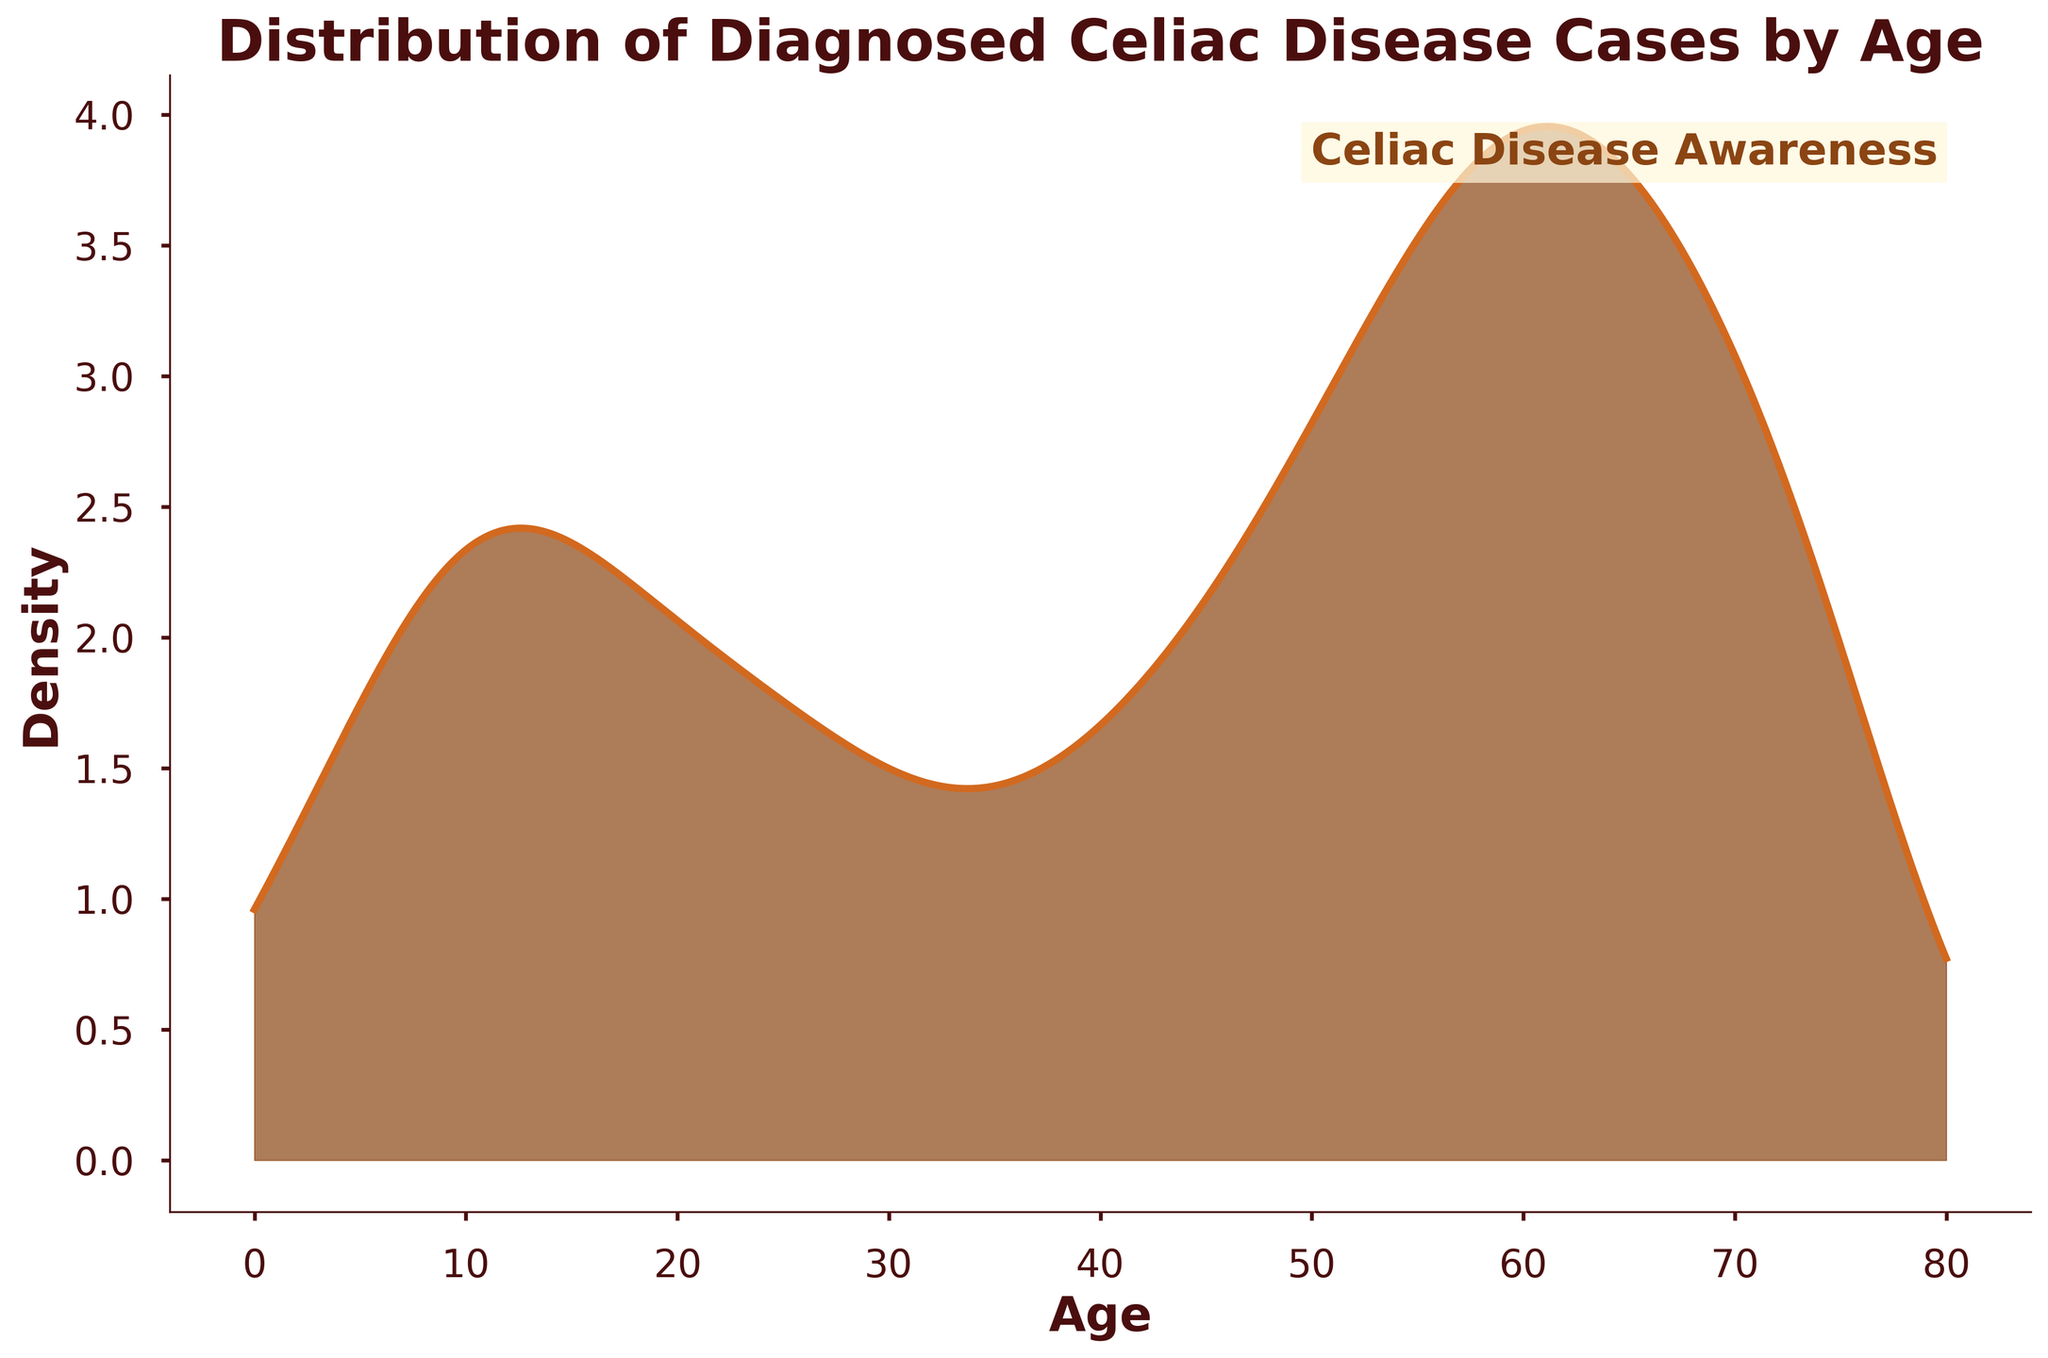What is the title of the plot? The title of the plot is located at the top of the figure and is displayed in bold.
Answer: Distribution of Diagnosed Celiac Disease Cases by Age What ages have the highest density of diagnosed Celiac disease cases? The highest density area in the figure corresponds to the peak of the plot, indicating the ages with the highest diagnosed cases.
Answer: 60-64 What is the lowest density area for diagnosed Celiac disease cases? The lowest density areas are where the plot dips closer to the baseline, indicating fewer diagnosed cases.
Answer: 0-4 How does the density of cases in the 20-24 age group compare to the 60-64 age group? The comparison involves looking at the height of the plot in the specified age ranges; the density is higher for the 60-64 group compared to the 20-24 group.
Answer: Less than Which age groups have similar densities of diagnosed Celiac disease cases? Look for areas on the plot where the curve appears at similar heights, indicating similar densities.
Answer: 45-49 and 75+ How does the density change from age 50-54 to age 60-64? Examine the plot's slope between these age ranges; the density increases as the curve rises from 50-54 to 60-64.
Answer: Increases Is there an overall trend in the distribution of diagnosed cases as age increases? Identify the overall shape and direction of the plot line as age progresses; generally, the density rises with age to a peak, then gradually decreases.
Answer: Rises, then falls How many age groups have densities higher than the 45-49 age group? Count the number of age groups with plot peaks that surpass the peak of the 45-49 age group.
Answer: Four What text is added for advocacy purposes in the plot? Look for additional annotations in the plot that serve as notices or advocacy messages.
Answer: Celiac Disease Awareness Which age group shows a marked increase in density compared to its preceding age group? Compare the plot's heights between consecutive age groups to find a significant rise.
Answer: 55-59 